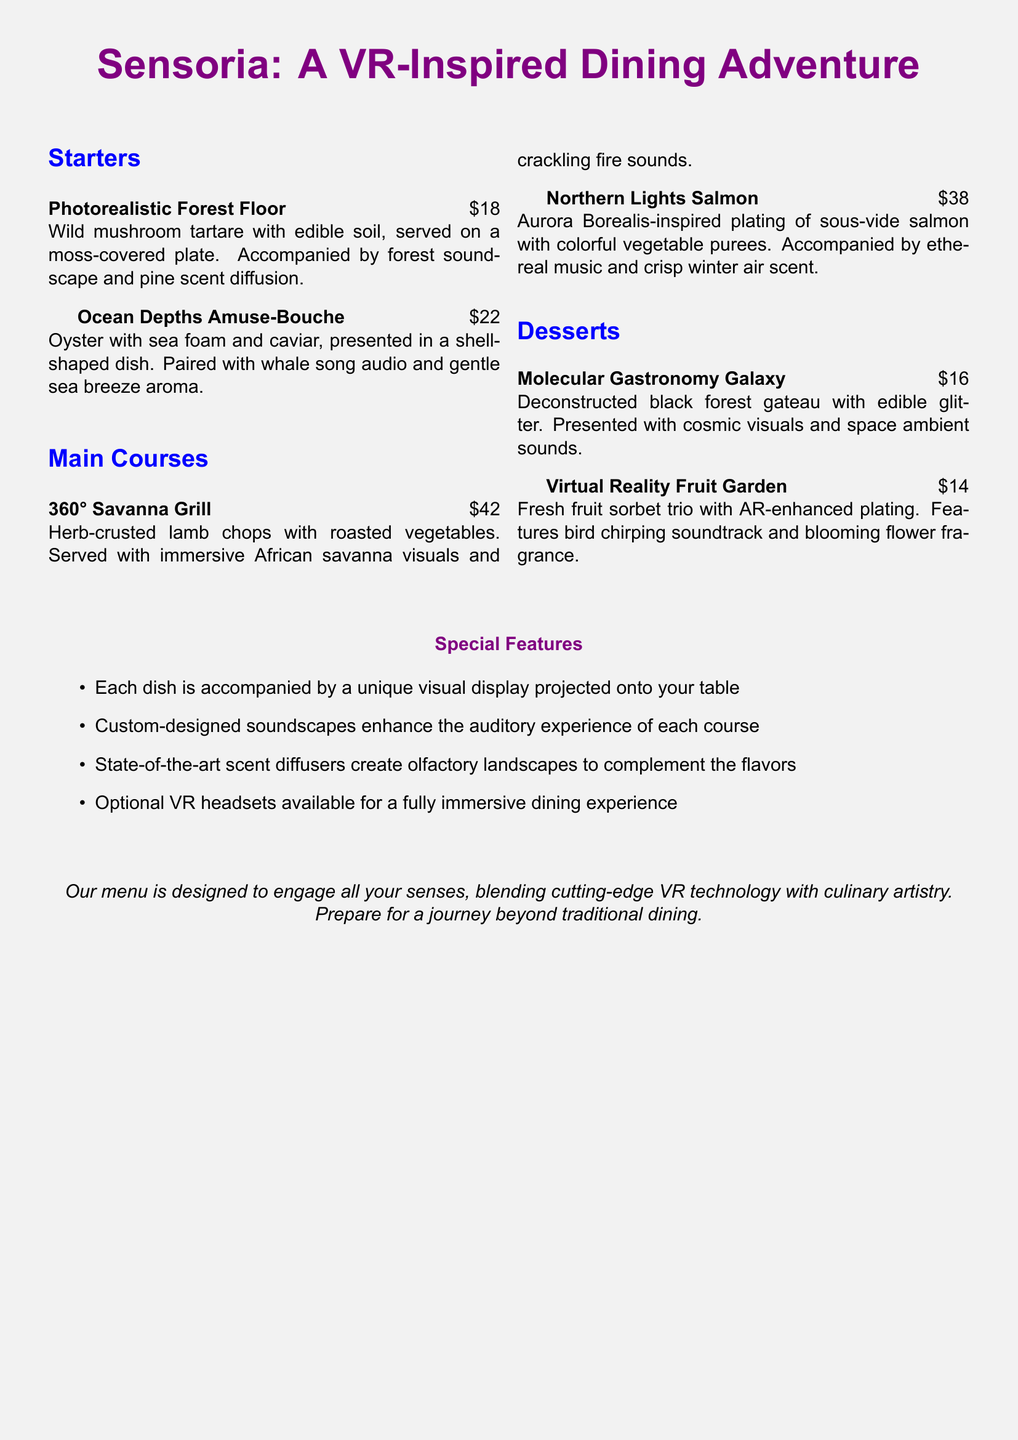what is the name of the first starter? The first starter is specifically titled in the menu as "Photorealistic Forest Floor."
Answer: Photorealistic Forest Floor how much does the Northern Lights Salmon cost? The price for the Northern Lights Salmon dish is stated clearly in the menu.
Answer: $38 what audio accompanies the Ocean Depths Amuse-Bouche? The menu specifies that the Ocean Depths Amuse-Bouche is paired with whale song audio.
Answer: whale song how many unique features are listed under Special Features? The menu outlines a specific number of features under the Special Features section.
Answer: four which main course is inspired by the African savanna? The menu explicitly mentions the main course related to the African savanna in its title.
Answer: 360° Savanna Grill what type of music is associated with the Northern Lights Salmon? The menu indicates the type of music paired with the Northern Lights Salmon dish.
Answer: ethereal music what edible elements are included in the Molecular Gastronomy Galaxy dessert? The Molecular Gastronomy Galaxy dessert mentions its edible components in the description.
Answer: edible glitter what floral scent is featured with the Virtual Reality Fruit Garden? The menu describes the scent accompanying the Virtual Reality Fruit Garden dish.
Answer: blooming flower fragrance 